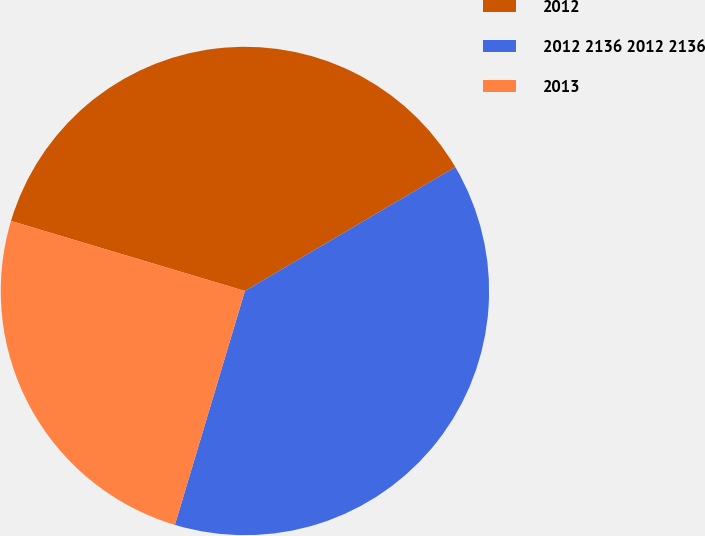<chart> <loc_0><loc_0><loc_500><loc_500><pie_chart><fcel>2012<fcel>2012 2136 2012 2136<fcel>2013<nl><fcel>36.9%<fcel>38.1%<fcel>25.0%<nl></chart> 